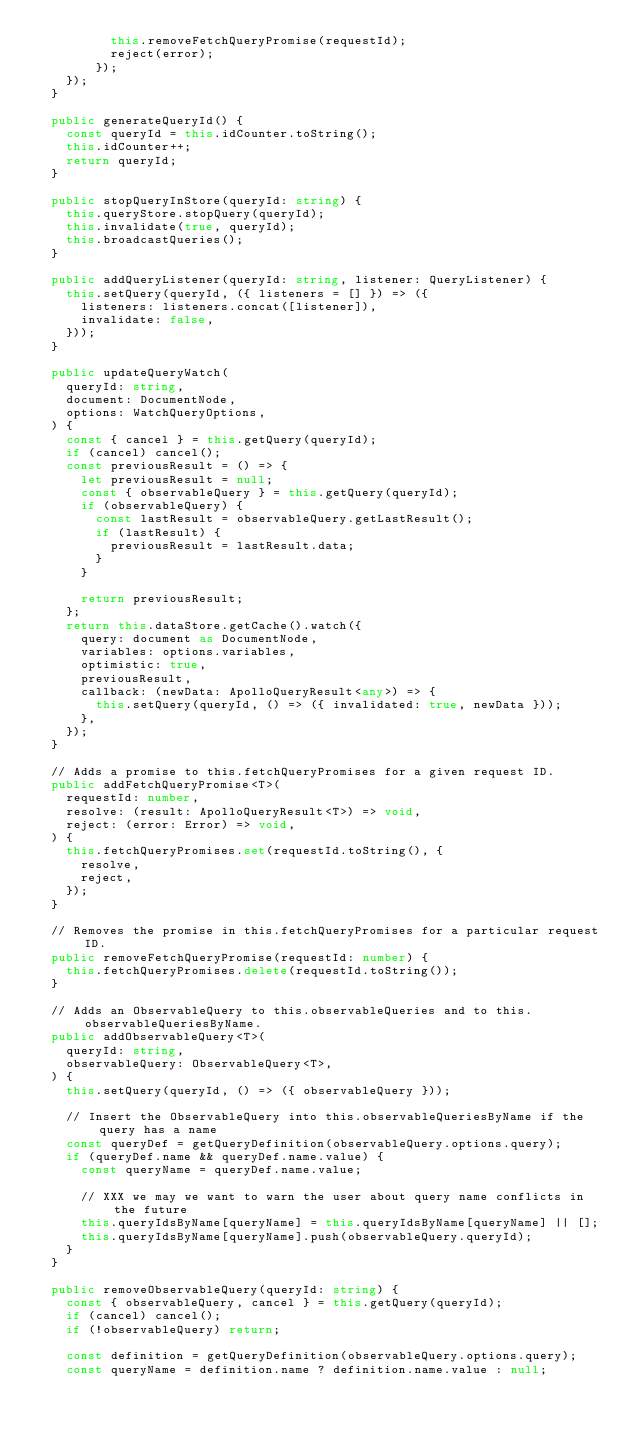Convert code to text. <code><loc_0><loc_0><loc_500><loc_500><_TypeScript_>          this.removeFetchQueryPromise(requestId);
          reject(error);
        });
    });
  }

  public generateQueryId() {
    const queryId = this.idCounter.toString();
    this.idCounter++;
    return queryId;
  }

  public stopQueryInStore(queryId: string) {
    this.queryStore.stopQuery(queryId);
    this.invalidate(true, queryId);
    this.broadcastQueries();
  }

  public addQueryListener(queryId: string, listener: QueryListener) {
    this.setQuery(queryId, ({ listeners = [] }) => ({
      listeners: listeners.concat([listener]),
      invalidate: false,
    }));
  }

  public updateQueryWatch(
    queryId: string,
    document: DocumentNode,
    options: WatchQueryOptions,
  ) {
    const { cancel } = this.getQuery(queryId);
    if (cancel) cancel();
    const previousResult = () => {
      let previousResult = null;
      const { observableQuery } = this.getQuery(queryId);
      if (observableQuery) {
        const lastResult = observableQuery.getLastResult();
        if (lastResult) {
          previousResult = lastResult.data;
        }
      }

      return previousResult;
    };
    return this.dataStore.getCache().watch({
      query: document as DocumentNode,
      variables: options.variables,
      optimistic: true,
      previousResult,
      callback: (newData: ApolloQueryResult<any>) => {
        this.setQuery(queryId, () => ({ invalidated: true, newData }));
      },
    });
  }

  // Adds a promise to this.fetchQueryPromises for a given request ID.
  public addFetchQueryPromise<T>(
    requestId: number,
    resolve: (result: ApolloQueryResult<T>) => void,
    reject: (error: Error) => void,
  ) {
    this.fetchQueryPromises.set(requestId.toString(), {
      resolve,
      reject,
    });
  }

  // Removes the promise in this.fetchQueryPromises for a particular request ID.
  public removeFetchQueryPromise(requestId: number) {
    this.fetchQueryPromises.delete(requestId.toString());
  }

  // Adds an ObservableQuery to this.observableQueries and to this.observableQueriesByName.
  public addObservableQuery<T>(
    queryId: string,
    observableQuery: ObservableQuery<T>,
  ) {
    this.setQuery(queryId, () => ({ observableQuery }));

    // Insert the ObservableQuery into this.observableQueriesByName if the query has a name
    const queryDef = getQueryDefinition(observableQuery.options.query);
    if (queryDef.name && queryDef.name.value) {
      const queryName = queryDef.name.value;

      // XXX we may we want to warn the user about query name conflicts in the future
      this.queryIdsByName[queryName] = this.queryIdsByName[queryName] || [];
      this.queryIdsByName[queryName].push(observableQuery.queryId);
    }
  }

  public removeObservableQuery(queryId: string) {
    const { observableQuery, cancel } = this.getQuery(queryId);
    if (cancel) cancel();
    if (!observableQuery) return;

    const definition = getQueryDefinition(observableQuery.options.query);
    const queryName = definition.name ? definition.name.value : null;</code> 